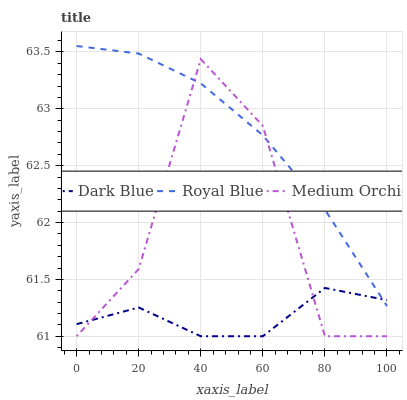Does Dark Blue have the minimum area under the curve?
Answer yes or no. Yes. Does Royal Blue have the maximum area under the curve?
Answer yes or no. Yes. Does Medium Orchid have the minimum area under the curve?
Answer yes or no. No. Does Medium Orchid have the maximum area under the curve?
Answer yes or no. No. Is Royal Blue the smoothest?
Answer yes or no. Yes. Is Medium Orchid the roughest?
Answer yes or no. Yes. Is Medium Orchid the smoothest?
Answer yes or no. No. Is Royal Blue the roughest?
Answer yes or no. No. Does Royal Blue have the lowest value?
Answer yes or no. No. Does Medium Orchid have the highest value?
Answer yes or no. No. 